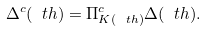Convert formula to latex. <formula><loc_0><loc_0><loc_500><loc_500>\Delta ^ { c } ( \ t h ) = \Pi ^ { c } _ { K ( \ t h ) } \Delta ( \ t h ) .</formula> 